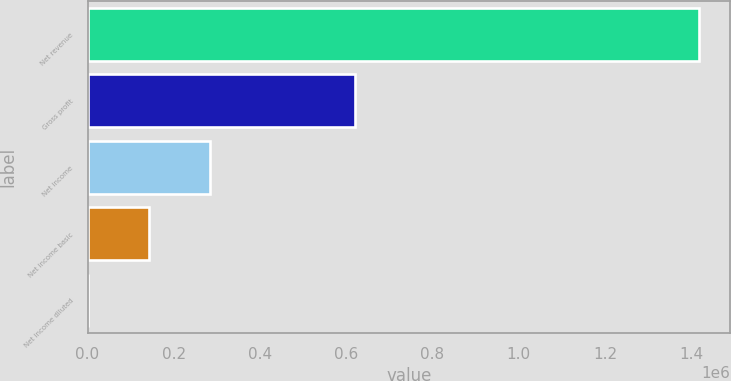Convert chart. <chart><loc_0><loc_0><loc_500><loc_500><bar_chart><fcel>Net revenue<fcel>Gross profit<fcel>Net income<fcel>Net income basic<fcel>Net income diluted<nl><fcel>1.41892e+06<fcel>620304<fcel>283785<fcel>141893<fcel>1.19<nl></chart> 